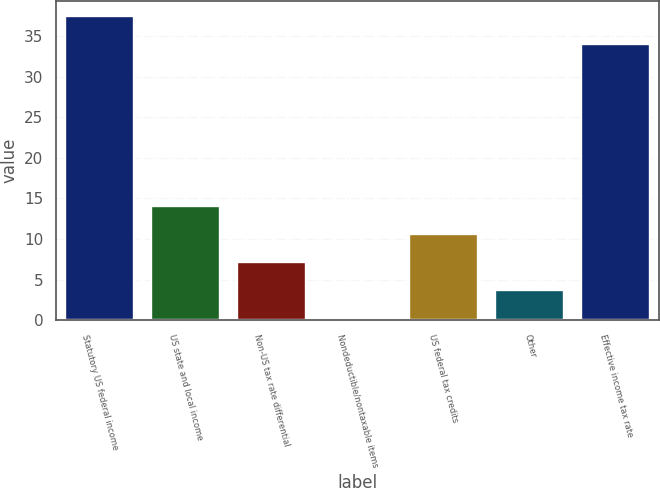Convert chart. <chart><loc_0><loc_0><loc_500><loc_500><bar_chart><fcel>Statutory US federal income<fcel>US state and local income<fcel>Non-US tax rate differential<fcel>Nondeductible/nontaxable items<fcel>US federal tax credits<fcel>Other<fcel>Effective income tax rate<nl><fcel>37.48<fcel>14.12<fcel>7.16<fcel>0.2<fcel>10.64<fcel>3.68<fcel>34<nl></chart> 